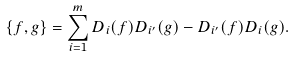<formula> <loc_0><loc_0><loc_500><loc_500>\{ f , g \} = \sum _ { i = 1 } ^ { m } D _ { i } ( f ) D _ { i ^ { \prime } } ( g ) - D _ { i ^ { \prime } } ( f ) D _ { i } ( g ) .</formula> 